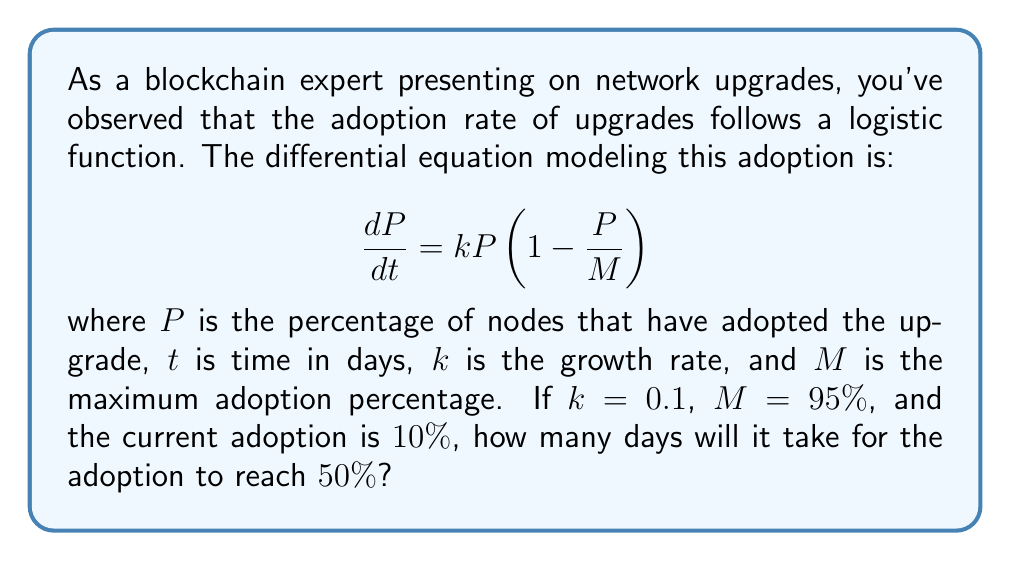Show me your answer to this math problem. To solve this problem, we need to use the solution to the logistic differential equation:

$$P(t) = \frac{M}{1 + (\frac{M}{P_0} - 1)e^{-kt}}$$

where $P_0$ is the initial adoption percentage.

Given:
- $k = 0.1$
- $M = 95\%$ = 0.95
- $P_0 = 10\%$ = 0.1
- We want to find $t$ when $P(t) = 50\%$ = 0.5

Step 1: Substitute the known values into the equation:

$$0.5 = \frac{0.95}{1 + (\frac{0.95}{0.1} - 1)e^{-0.1t}}$$

Step 2: Solve for $t$:

$$0.5(1 + (\frac{0.95}{0.1} - 1)e^{-0.1t}) = 0.95$$
$$1 + (\frac{0.95}{0.1} - 1)e^{-0.1t} = 1.9$$
$$(\frac{0.95}{0.1} - 1)e^{-0.1t} = 0.9$$
$$e^{-0.1t} = \frac{0.9}{8.5} = \frac{0.9}{9.5-1} = \frac{0.9}{9.5-1}$$

$$-0.1t = \ln(\frac{0.9}{8.5})$$

$$t = -\frac{1}{0.1}\ln(\frac{0.9}{8.5}) \approx 22.97$$

Therefore, it will take approximately 23 days for the adoption to reach 50%.
Answer: 23 days 